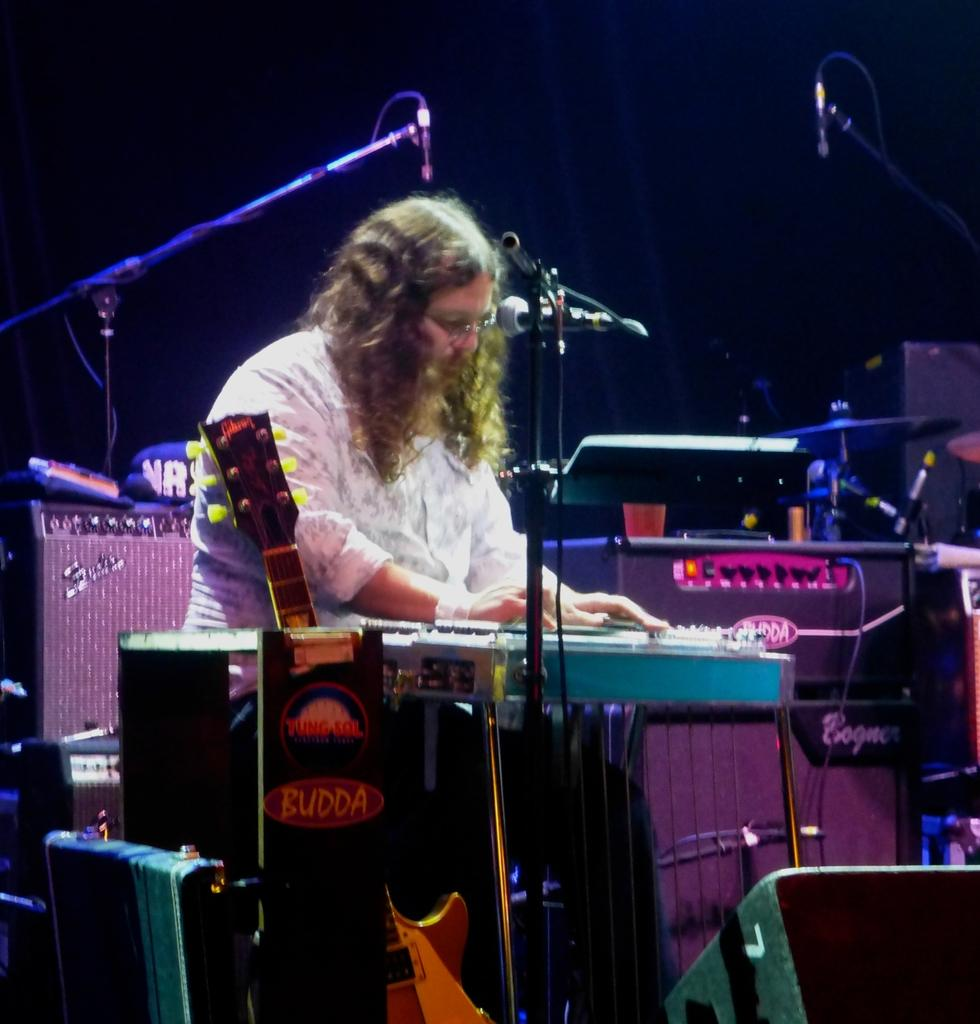What can be seen in the image? There is a person in the image. Can you describe the person's appearance? The person is wearing clothes and spectacles. What is the person doing in the image? The person is sitting. What objects are present in the image related to sound or music? There is a microphone and musical instruments in the image. Are there any cables or wires visible in the image? Yes, there is a cable wire in the image. How many chairs are visible in the image? There are no chairs visible in the image. What type of screw is being used to hold the shelf in place in the image? There is no shelf present in the image, so it is not possible to determine what type of screw might be used. 